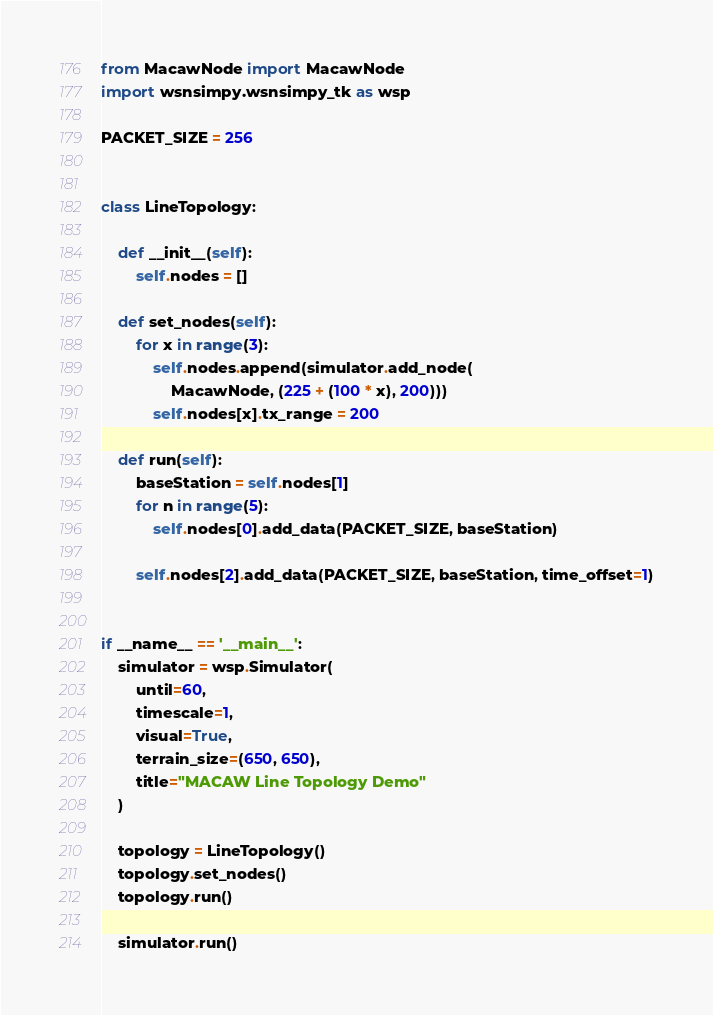<code> <loc_0><loc_0><loc_500><loc_500><_Python_>from MacawNode import MacawNode
import wsnsimpy.wsnsimpy_tk as wsp

PACKET_SIZE = 256


class LineTopology:

    def __init__(self):
        self.nodes = []

    def set_nodes(self):
        for x in range(3):
            self.nodes.append(simulator.add_node(
                MacawNode, (225 + (100 * x), 200)))
            self.nodes[x].tx_range = 200

    def run(self):
        baseStation = self.nodes[1]
        for n in range(5):
            self.nodes[0].add_data(PACKET_SIZE, baseStation)

        self.nodes[2].add_data(PACKET_SIZE, baseStation, time_offset=1)


if __name__ == '__main__':
    simulator = wsp.Simulator(
        until=60,
        timescale=1,
        visual=True,
        terrain_size=(650, 650),
        title="MACAW Line Topology Demo"
    )

    topology = LineTopology()
    topology.set_nodes()
    topology.run()

    simulator.run()
</code> 